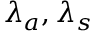Convert formula to latex. <formula><loc_0><loc_0><loc_500><loc_500>\lambda _ { a } , \lambda _ { s }</formula> 